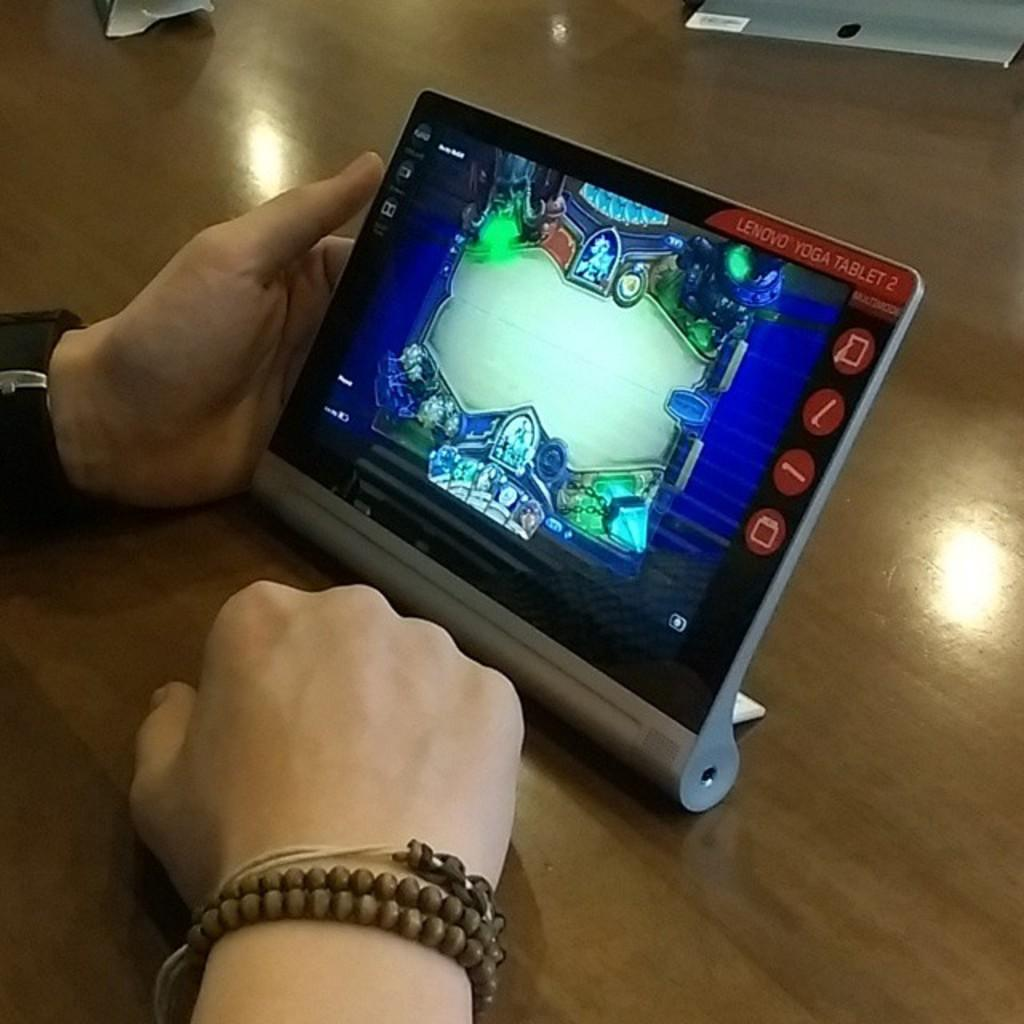What objects are present in the image involving hands? There are two hands in the image, and they are on a table. What activity are the hands engaged in? A: The hands are catching and using an iPad for playing a game. Are there any accessories visible on the hands? Yes, one of the hands has a wristwatch on it. What type of quill is being used to write on the iPad in the image? There is no quill present in the image; the hands are using the iPad for playing a game, not writing. How many cubs are visible in the image? There are no cubs present in the image. 